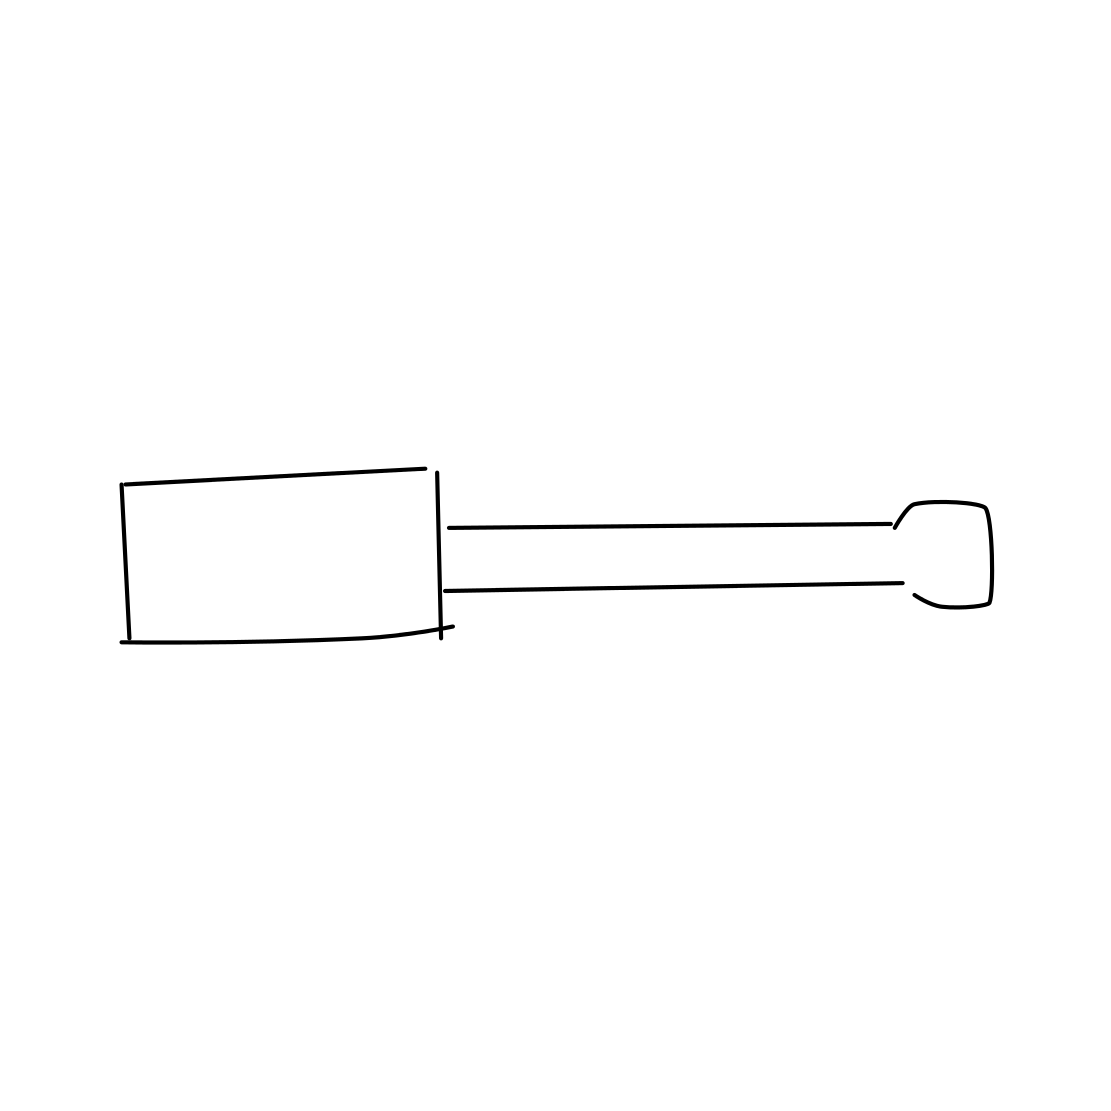Can you describe the size and possible applications of this screwdriver? The screwdriver appears to be of a standard size, likely around 6 to 8 inches long. It's suitable for various tasks such as tightening or loosening flathead screws found in furniture, electrical outlets, and small appliances. 